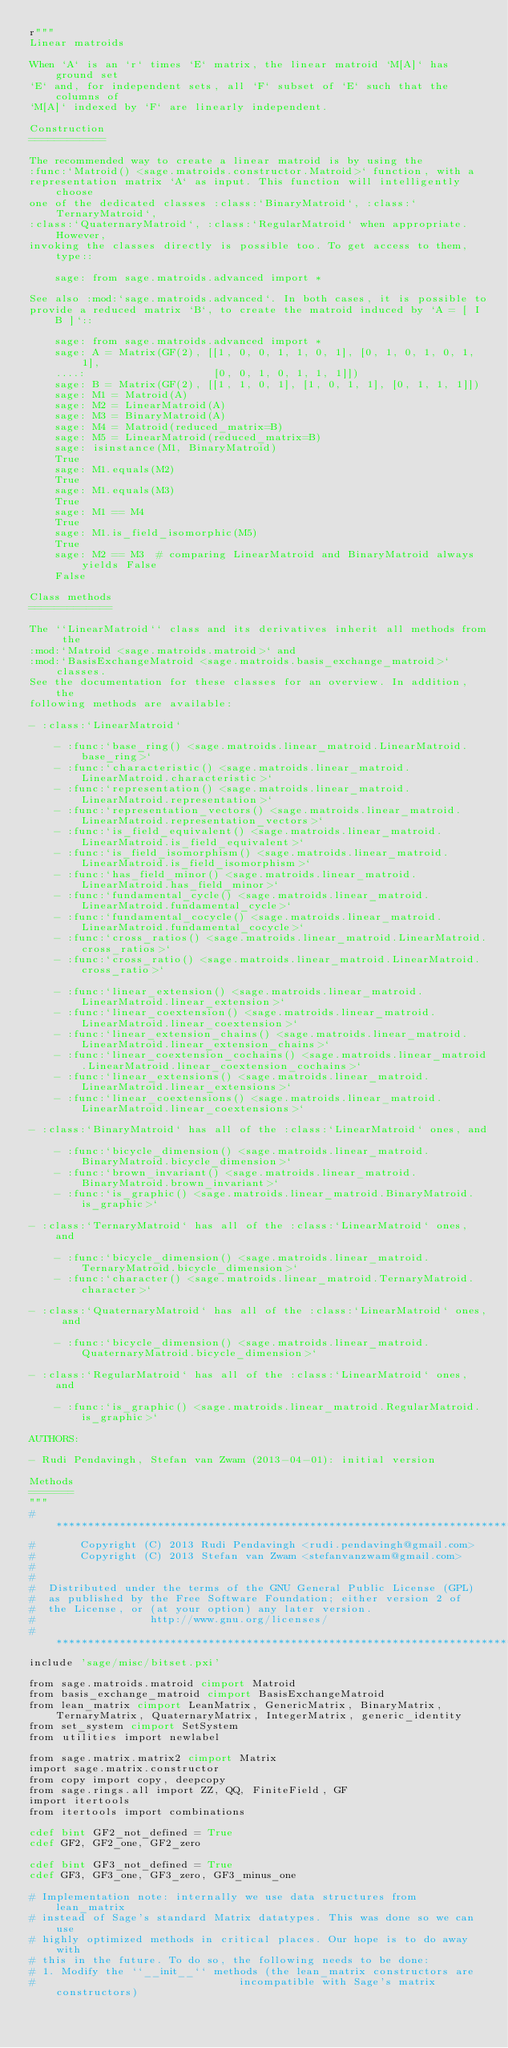<code> <loc_0><loc_0><loc_500><loc_500><_Cython_>r"""
Linear matroids

When `A` is an `r` times `E` matrix, the linear matroid `M[A]` has ground set
`E` and, for independent sets, all `F` subset of `E` such that the columns of
`M[A]` indexed by `F` are linearly independent.

Construction
============

The recommended way to create a linear matroid is by using the
:func:`Matroid() <sage.matroids.constructor.Matroid>` function, with a
representation matrix `A` as input. This function will intelligently choose
one of the dedicated classes :class:`BinaryMatroid`, :class:`TernaryMatroid`,
:class:`QuaternaryMatroid`, :class:`RegularMatroid` when appropriate. However,
invoking the classes directly is possible too. To get access to them, type::

    sage: from sage.matroids.advanced import *

See also :mod:`sage.matroids.advanced`. In both cases, it is possible to
provide a reduced matrix `B`, to create the matroid induced by `A = [ I B ]`::

    sage: from sage.matroids.advanced import *
    sage: A = Matrix(GF(2), [[1, 0, 0, 1, 1, 0, 1], [0, 1, 0, 1, 0, 1, 1],
    ....:                    [0, 0, 1, 0, 1, 1, 1]])
    sage: B = Matrix(GF(2), [[1, 1, 0, 1], [1, 0, 1, 1], [0, 1, 1, 1]])
    sage: M1 = Matroid(A)
    sage: M2 = LinearMatroid(A)
    sage: M3 = BinaryMatroid(A)
    sage: M4 = Matroid(reduced_matrix=B)
    sage: M5 = LinearMatroid(reduced_matrix=B)
    sage: isinstance(M1, BinaryMatroid)
    True
    sage: M1.equals(M2)
    True
    sage: M1.equals(M3)
    True
    sage: M1 == M4
    True
    sage: M1.is_field_isomorphic(M5)
    True
    sage: M2 == M3  # comparing LinearMatroid and BinaryMatroid always yields False
    False

Class methods
=============

The ``LinearMatroid`` class and its derivatives inherit all methods from the
:mod:`Matroid <sage.matroids.matroid>` and
:mod:`BasisExchangeMatroid <sage.matroids.basis_exchange_matroid>` classes.
See the documentation for these classes for an overview. In addition, the
following methods are available:

- :class:`LinearMatroid`

    - :func:`base_ring() <sage.matroids.linear_matroid.LinearMatroid.base_ring>`
    - :func:`characteristic() <sage.matroids.linear_matroid.LinearMatroid.characteristic>`
    - :func:`representation() <sage.matroids.linear_matroid.LinearMatroid.representation>`
    - :func:`representation_vectors() <sage.matroids.linear_matroid.LinearMatroid.representation_vectors>`
    - :func:`is_field_equivalent() <sage.matroids.linear_matroid.LinearMatroid.is_field_equivalent>`
    - :func:`is_field_isomorphism() <sage.matroids.linear_matroid.LinearMatroid.is_field_isomorphism>`
    - :func:`has_field_minor() <sage.matroids.linear_matroid.LinearMatroid.has_field_minor>`
    - :func:`fundamental_cycle() <sage.matroids.linear_matroid.LinearMatroid.fundamental_cycle>`
    - :func:`fundamental_cocycle() <sage.matroids.linear_matroid.LinearMatroid.fundamental_cocycle>`
    - :func:`cross_ratios() <sage.matroids.linear_matroid.LinearMatroid.cross_ratios>`
    - :func:`cross_ratio() <sage.matroids.linear_matroid.LinearMatroid.cross_ratio>`

    - :func:`linear_extension() <sage.matroids.linear_matroid.LinearMatroid.linear_extension>`
    - :func:`linear_coextension() <sage.matroids.linear_matroid.LinearMatroid.linear_coextension>`
    - :func:`linear_extension_chains() <sage.matroids.linear_matroid.LinearMatroid.linear_extension_chains>`
    - :func:`linear_coextension_cochains() <sage.matroids.linear_matroid.LinearMatroid.linear_coextension_cochains>`
    - :func:`linear_extensions() <sage.matroids.linear_matroid.LinearMatroid.linear_extensions>`
    - :func:`linear_coextensions() <sage.matroids.linear_matroid.LinearMatroid.linear_coextensions>`

- :class:`BinaryMatroid` has all of the :class:`LinearMatroid` ones, and

    - :func:`bicycle_dimension() <sage.matroids.linear_matroid.BinaryMatroid.bicycle_dimension>`
    - :func:`brown_invariant() <sage.matroids.linear_matroid.BinaryMatroid.brown_invariant>`
    - :func:`is_graphic() <sage.matroids.linear_matroid.BinaryMatroid.is_graphic>`

- :class:`TernaryMatroid` has all of the :class:`LinearMatroid` ones, and

    - :func:`bicycle_dimension() <sage.matroids.linear_matroid.TernaryMatroid.bicycle_dimension>`
    - :func:`character() <sage.matroids.linear_matroid.TernaryMatroid.character>`

- :class:`QuaternaryMatroid` has all of the :class:`LinearMatroid` ones, and

    - :func:`bicycle_dimension() <sage.matroids.linear_matroid.QuaternaryMatroid.bicycle_dimension>`

- :class:`RegularMatroid` has all of the :class:`LinearMatroid` ones, and

    - :func:`is_graphic() <sage.matroids.linear_matroid.RegularMatroid.is_graphic>`

AUTHORS:

- Rudi Pendavingh, Stefan van Zwam (2013-04-01): initial version

Methods
=======
"""
#*****************************************************************************
#       Copyright (C) 2013 Rudi Pendavingh <rudi.pendavingh@gmail.com>
#       Copyright (C) 2013 Stefan van Zwam <stefanvanzwam@gmail.com>
#
#
#  Distributed under the terms of the GNU General Public License (GPL)
#  as published by the Free Software Foundation; either version 2 of
#  the License, or (at your option) any later version.
#                  http://www.gnu.org/licenses/
#*****************************************************************************
include 'sage/misc/bitset.pxi'

from sage.matroids.matroid cimport Matroid
from basis_exchange_matroid cimport BasisExchangeMatroid
from lean_matrix cimport LeanMatrix, GenericMatrix, BinaryMatrix, TernaryMatrix, QuaternaryMatrix, IntegerMatrix, generic_identity
from set_system cimport SetSystem
from utilities import newlabel

from sage.matrix.matrix2 cimport Matrix
import sage.matrix.constructor
from copy import copy, deepcopy
from sage.rings.all import ZZ, QQ, FiniteField, GF
import itertools
from itertools import combinations

cdef bint GF2_not_defined = True
cdef GF2, GF2_one, GF2_zero

cdef bint GF3_not_defined = True
cdef GF3, GF3_one, GF3_zero, GF3_minus_one

# Implementation note: internally we use data structures from lean_matrix
# instead of Sage's standard Matrix datatypes. This was done so we can use
# highly optimized methods in critical places. Our hope is to do away with
# this in the future. To do so, the following needs to be done:
# 1. Modify the ``__init__`` methods (the lean_matrix constructors are
#                                incompatible with Sage's matrix constructors)</code> 